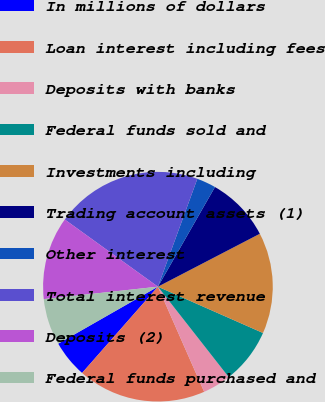<chart> <loc_0><loc_0><loc_500><loc_500><pie_chart><fcel>In millions of dollars<fcel>Loan interest including fees<fcel>Deposits with banks<fcel>Federal funds sold and<fcel>Investments including<fcel>Trading account assets (1)<fcel>Other interest<fcel>Total interest revenue<fcel>Deposits (2)<fcel>Federal funds purchased and<nl><fcel>5.26%<fcel>18.07%<fcel>3.98%<fcel>7.82%<fcel>14.23%<fcel>9.1%<fcel>2.7%<fcel>20.63%<fcel>11.67%<fcel>6.54%<nl></chart> 